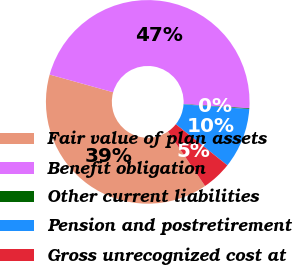Convert chart. <chart><loc_0><loc_0><loc_500><loc_500><pie_chart><fcel>Fair value of plan assets<fcel>Benefit obligation<fcel>Other current liabilities<fcel>Pension and postretirement<fcel>Gross unrecognized cost at<nl><fcel>38.84%<fcel>46.69%<fcel>0.11%<fcel>9.58%<fcel>4.77%<nl></chart> 